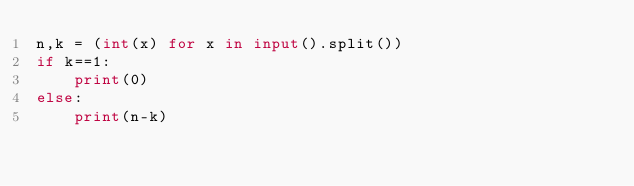Convert code to text. <code><loc_0><loc_0><loc_500><loc_500><_Python_>n,k = (int(x) for x in input().split())
if k==1:
    print(0)
else:
    print(n-k)</code> 